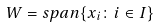<formula> <loc_0><loc_0><loc_500><loc_500>W = s p a n \{ x _ { i } \colon i \in I \}</formula> 